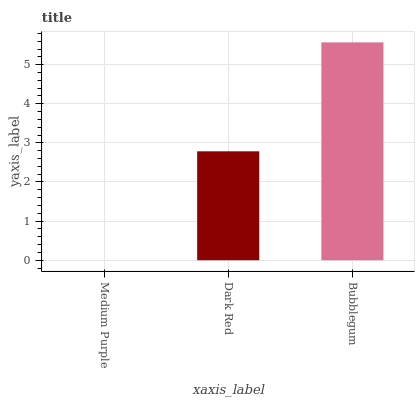Is Medium Purple the minimum?
Answer yes or no. Yes. Is Bubblegum the maximum?
Answer yes or no. Yes. Is Dark Red the minimum?
Answer yes or no. No. Is Dark Red the maximum?
Answer yes or no. No. Is Dark Red greater than Medium Purple?
Answer yes or no. Yes. Is Medium Purple less than Dark Red?
Answer yes or no. Yes. Is Medium Purple greater than Dark Red?
Answer yes or no. No. Is Dark Red less than Medium Purple?
Answer yes or no. No. Is Dark Red the high median?
Answer yes or no. Yes. Is Dark Red the low median?
Answer yes or no. Yes. Is Bubblegum the high median?
Answer yes or no. No. Is Medium Purple the low median?
Answer yes or no. No. 